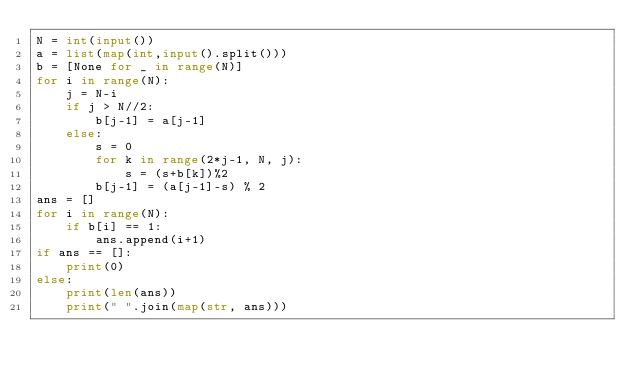<code> <loc_0><loc_0><loc_500><loc_500><_Python_>N = int(input())
a = list(map(int,input().split()))
b = [None for _ in range(N)]
for i in range(N):
    j = N-i
    if j > N//2:
        b[j-1] = a[j-1]
    else:
        s = 0
        for k in range(2*j-1, N, j):
            s = (s+b[k])%2
        b[j-1] = (a[j-1]-s) % 2
ans = []
for i in range(N):
    if b[i] == 1:
        ans.append(i+1)
if ans == []:
    print(0)
else:
    print(len(ans))
    print(" ".join(map(str, ans)))</code> 